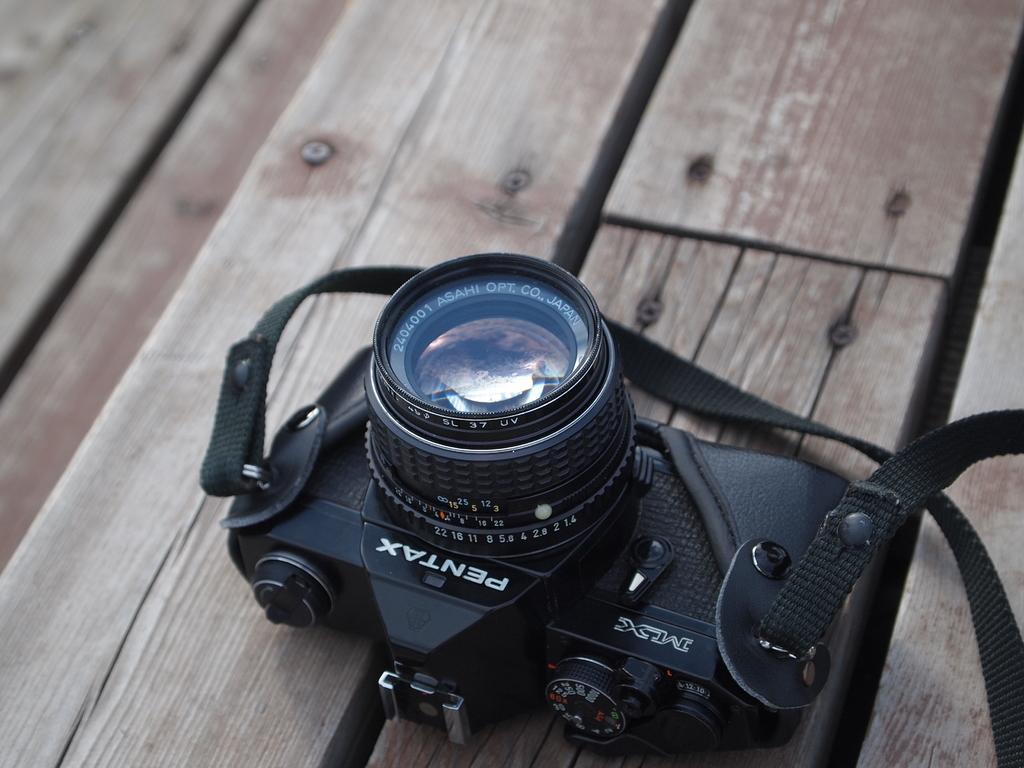In one or two sentences, can you explain what this image depicts? In the image there is a black camera on a wooden table. 